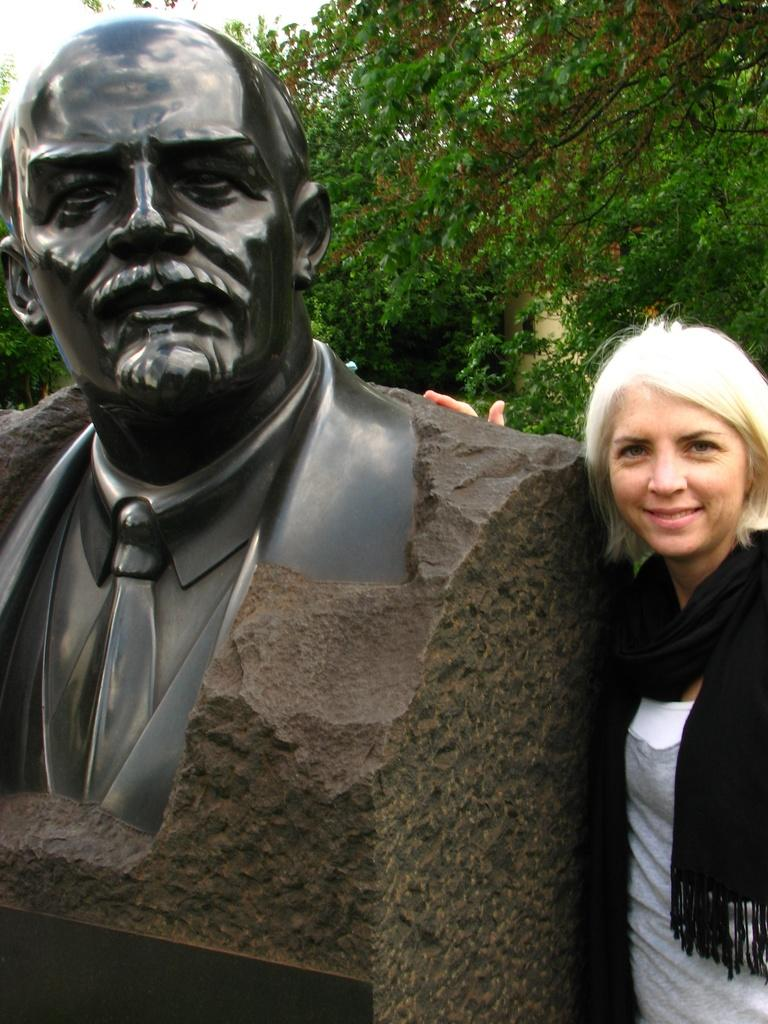Who is present in the image? There is a woman in the image. What is the woman standing on? The woman is standing on a path. What is located on the left side of the woman? There is a statue on the left side of the woman. What is behind the woman? There is a wall behind the woman. What can be seen in the distance in the image? Trees and the sky are visible in the background. What type of shop can be seen in the background of the image? There is no shop visible in the background of the image; it features a wall, trees, and the sky. What type of farm animals are present in the image? There are no farm animals present in the image; it features a woman, a statue, a wall, trees, and the sky. 